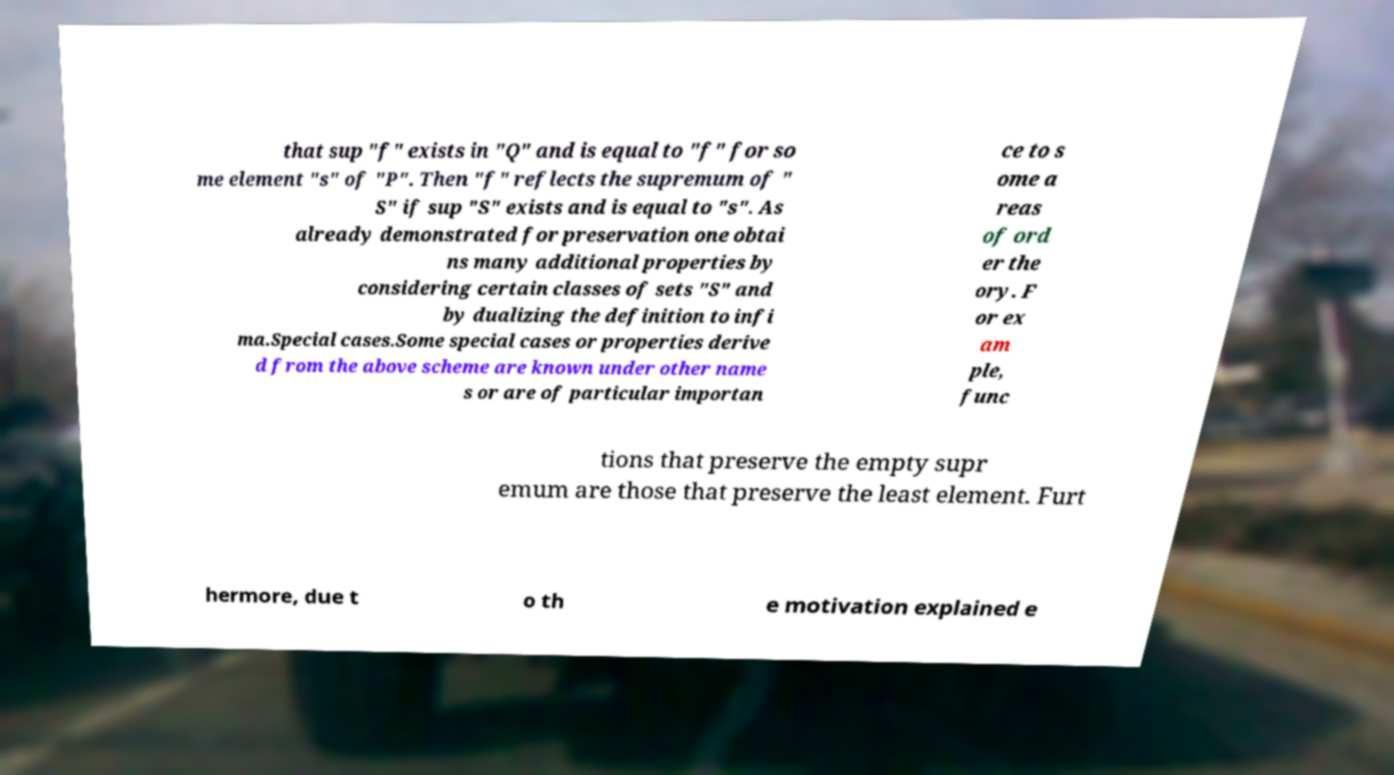Can you accurately transcribe the text from the provided image for me? that sup "f" exists in "Q" and is equal to "f" for so me element "s" of "P". Then "f" reflects the supremum of " S" if sup "S" exists and is equal to "s". As already demonstrated for preservation one obtai ns many additional properties by considering certain classes of sets "S" and by dualizing the definition to infi ma.Special cases.Some special cases or properties derive d from the above scheme are known under other name s or are of particular importan ce to s ome a reas of ord er the ory. F or ex am ple, func tions that preserve the empty supr emum are those that preserve the least element. Furt hermore, due t o th e motivation explained e 